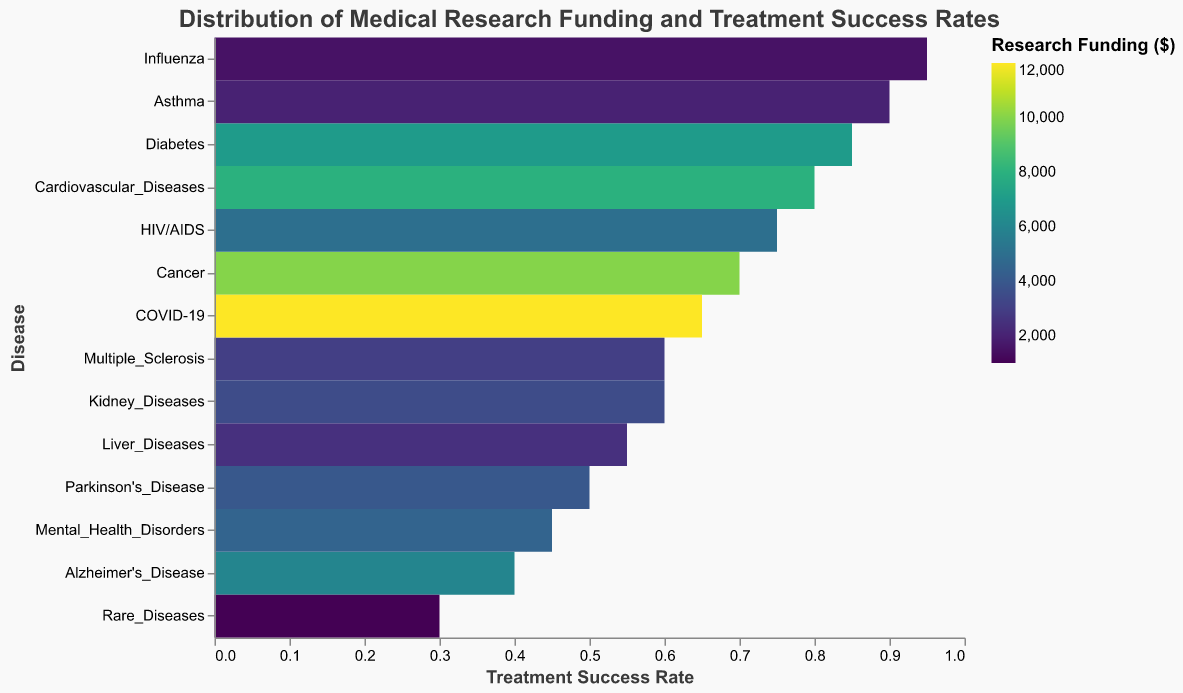What disease has the highest treatment success rate? The treatment success rates can be found on the x-axis. By scanning the chart for the maximum value along the x-axis, we see that Influenza has the highest treatment success rate.
Answer: Influenza Which disease has the lowest research funding? The research funding is represented by the color of the rectangles, with darker colors indicating higher funding. By locating the lightest colored rectangle, we see that Rare Diseases have the lowest funding.
Answer: Rare Diseases What is the treatment success rate for COVID-19? Locate COVID-19 on the y-axis, then follow horizontally to the x-axis to read the corresponding treatment success rate. The treatment success rate for COVID-19 is 0.65.
Answer: 0.65 Which disease has a higher treatment success rate, Alzheimer's Disease or Parkinson's Disease? Compare the treatment success rates along the x-axis for Alzheimer's Disease and Parkinson's Disease. Alzheimer's Disease has a treatment success rate of 0.40, and Parkinson's Disease has a rate of 0.50. Therefore, Parkinson's Disease has a higher treatment success rate.
Answer: Parkinson's Disease What is the median treatment success rate across all diseases? List the treatment success rates in ascending order and find the middle value. The treatment success rates are: 0.30, 0.40, 0.45, 0.50, 0.55, 0.60, 0.60, 0.65, 0.70, 0.75, 0.80, 0.85, 0.90, 0.95. The median value is between 0.60 and 0.60, so the median is 0.60.
Answer: 0.60 Which disease has the highest research funding and what is its treatment success rate? The highest research funding is indicated by the darkest color. Identify the darkest rectangle, which corresponds to COVID-19. Its treatment success rate can be found by looking at its position along the x-axis, which is 0.65.
Answer: COVID-19 with a rate of 0.65 How many diseases have treatment success rates above 0.70? Count the number of rectangles positioned to the right of the 0.70 mark on the x-axis. Diseases with success rates above 0.70 are: Cancer, Cardiovascular Diseases, Diabetes, HIV/AIDS, Asthma, and Influenza. There are 6 such diseases.
Answer: 6 Which disease has a moderate amount of research funding but a low treatment success rate? Moderate research funding can be determined by mid-range color shades, and low treatment success rates are to the left on the x-axis. By evaluating both criteria, we find that Mental Health Disorders match this description with funding of 4500 and a success rate of 0.45.
Answer: Mental Health Disorders What is the average research funding for the diseases listed? Sum all research funding values and divide by the number of diseases. Funding values: 10000, 8000, 6000, 7000, 4000, 3000, 5000, 2000, 1500, 12000, 2500, 3500, 4500, 1000. The total is 70750, and there are 14 diseases. The average funding is 70750 / 14 = 5053.57.
Answer: 5053.57 